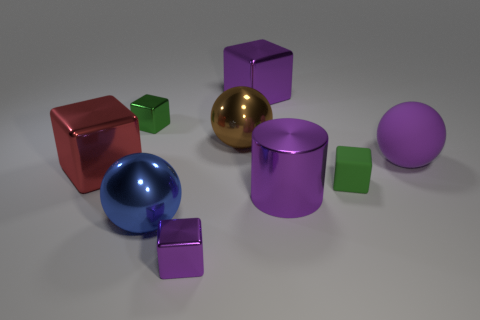Can you describe the lighting in this scene? The lighting in the scene is soft and diffused, coming from above and creating gentle shadows under the objects, suggesting an evenly lit indoor environment. 